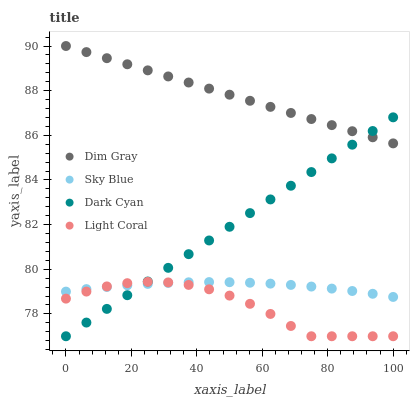Does Light Coral have the minimum area under the curve?
Answer yes or no. Yes. Does Dim Gray have the maximum area under the curve?
Answer yes or no. Yes. Does Sky Blue have the minimum area under the curve?
Answer yes or no. No. Does Sky Blue have the maximum area under the curve?
Answer yes or no. No. Is Dark Cyan the smoothest?
Answer yes or no. Yes. Is Light Coral the roughest?
Answer yes or no. Yes. Is Sky Blue the smoothest?
Answer yes or no. No. Is Sky Blue the roughest?
Answer yes or no. No. Does Dark Cyan have the lowest value?
Answer yes or no. Yes. Does Sky Blue have the lowest value?
Answer yes or no. No. Does Dim Gray have the highest value?
Answer yes or no. Yes. Does Sky Blue have the highest value?
Answer yes or no. No. Is Light Coral less than Dim Gray?
Answer yes or no. Yes. Is Dim Gray greater than Light Coral?
Answer yes or no. Yes. Does Dim Gray intersect Dark Cyan?
Answer yes or no. Yes. Is Dim Gray less than Dark Cyan?
Answer yes or no. No. Is Dim Gray greater than Dark Cyan?
Answer yes or no. No. Does Light Coral intersect Dim Gray?
Answer yes or no. No. 